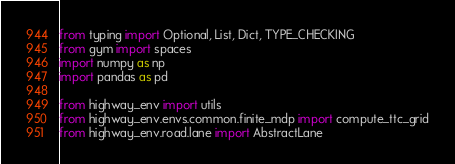Convert code to text. <code><loc_0><loc_0><loc_500><loc_500><_Python_>from typing import Optional, List, Dict, TYPE_CHECKING
from gym import spaces
import numpy as np
import pandas as pd

from highway_env import utils
from highway_env.envs.common.finite_mdp import compute_ttc_grid
from highway_env.road.lane import AbstractLane</code> 